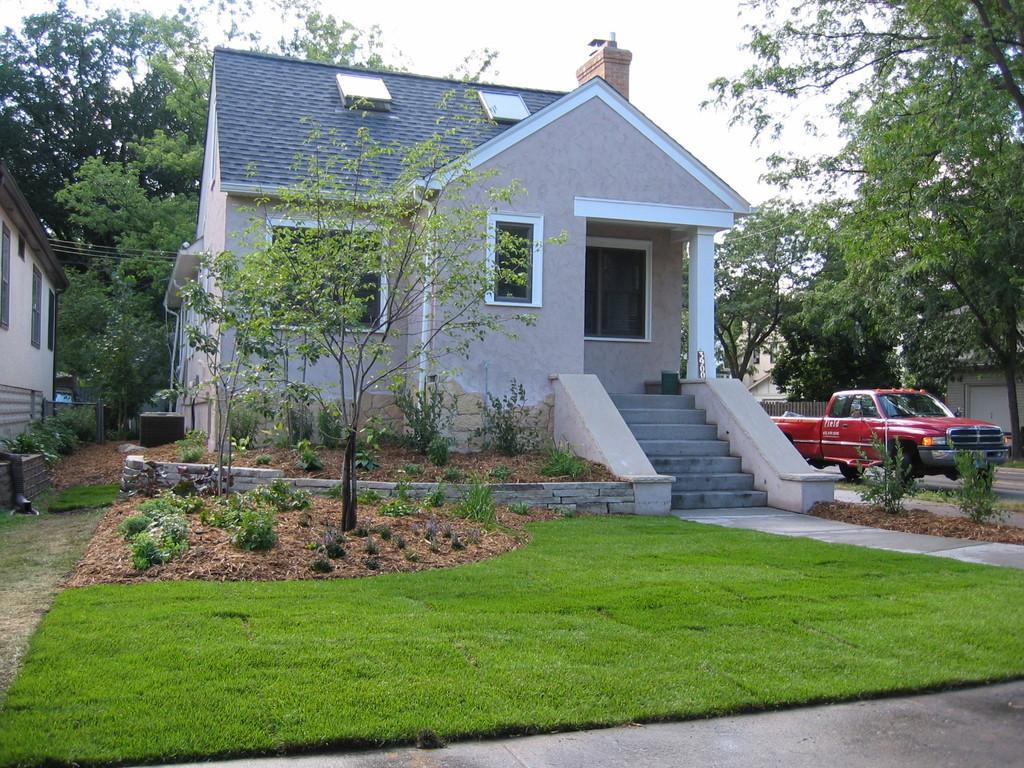How would you summarize this image in a sentence or two? In this image I can see the houses. In-front of the houses I can see the plants. To the right I can see the vehicle. In the background I can see many trees and the sky. 